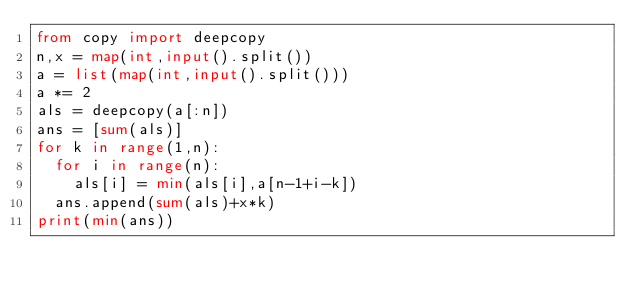Convert code to text. <code><loc_0><loc_0><loc_500><loc_500><_Python_>from copy import deepcopy
n,x = map(int,input().split())
a = list(map(int,input().split()))
a *= 2
als = deepcopy(a[:n])
ans = [sum(als)]
for k in range(1,n):
  for i in range(n):
    als[i] = min(als[i],a[n-1+i-k])
  ans.append(sum(als)+x*k)
print(min(ans))</code> 